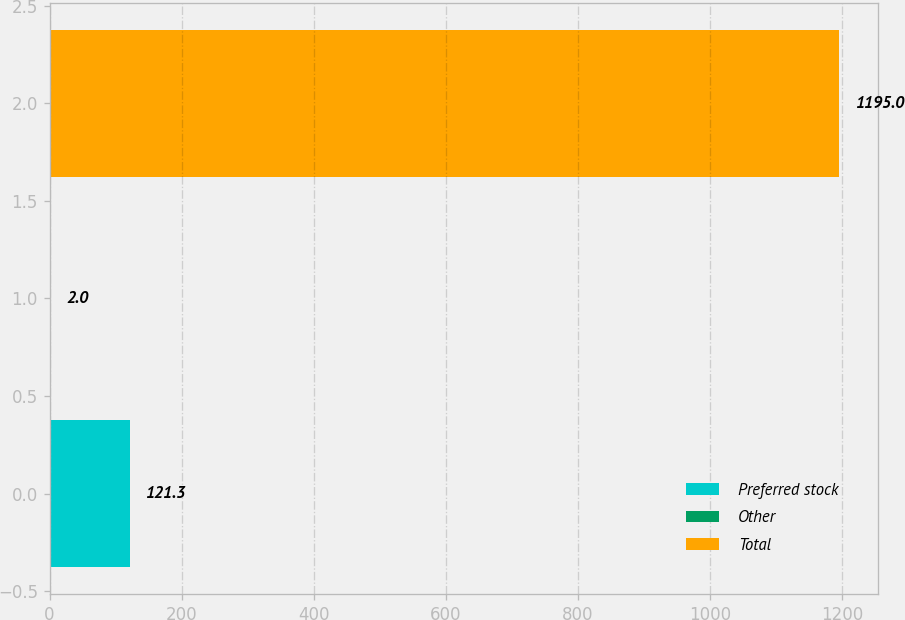<chart> <loc_0><loc_0><loc_500><loc_500><bar_chart><fcel>Preferred stock<fcel>Other<fcel>Total<nl><fcel>121.3<fcel>2<fcel>1195<nl></chart> 